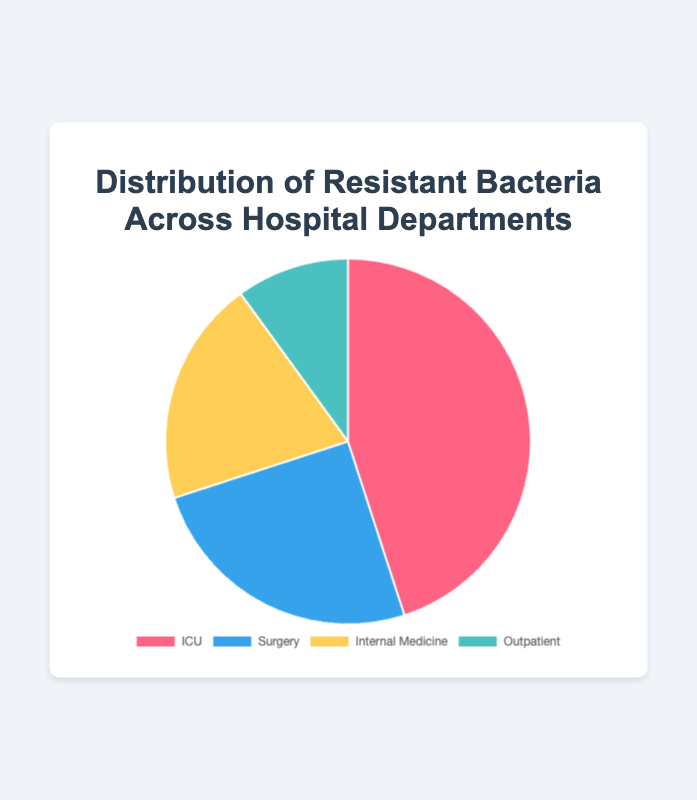Which department has the highest percentage of resistant bacteria? The department with the largest portion of the pie chart represents the highest percentage. The ICU department has the largest portion.
Answer: ICU What is the combined percentage of resistant bacteria in the Surgery and Internal Medicine departments? Add the percentages of resistant bacteria in the Surgery (25%) and Internal Medicine (20%) departments: 25% + 20% = 45%.
Answer: 45% Which department has the smallest percentage of resistant bacteria, and what is that percentage? The department with the smallest portion of the pie chart has the smallest percentage. The Outpatient department has the smallest portion, and its percentage is 10%.
Answer: Outpatient, 10% By how much does the percentage of resistant bacteria in the ICU department exceed that in the Outpatient department? Subtract the percentage of resistant bacteria in the Outpatient department (10%) from that in the ICU department (45%): 45% - 10% = 35%.
Answer: 35% What is the average percentage of resistant bacteria across all four departments? Add the percentages of resistant bacteria in all departments and then divide by the number of departments: (45% + 25% + 20% + 10%) / 4 = 100% / 4 = 25%.
Answer: 25% Which departments have a resistant bacteria percentage greater than 20%? Compare the percentages of all departments to find those greater than 20%. Both ICU (45%) and Surgery (25%) have percentages greater than 20%.
Answer: ICU, Surgery Which department's slice of the pie chart is colored yellow, and what is its percentage of resistant bacteria? Look at the color coding in the chart. The yellow slice represents Internal Medicine, which has 20% resistant bacteria.
Answer: Internal Medicine, 20% What is the difference in the percentage of resistant bacteria between the Surgery and Internal Medicine departments? Subtract the percentage in the Internal Medicine department (20%) from that in the Surgery department (25%): 25% - 20% = 5%.
Answer: 5% If you combine the resistant bacteria percentages of the departments with the smallest and largest values, what is the resulting percentage? Add the smallest percentage (Outpatient, 10%) to the largest percentage (ICU, 45%): 10% + 45% = 55%.
Answer: 55% What fraction of the total resistant bacteria does the Internal Medicine department represent? Divide the percentage of Internal Medicine resistant bacteria by the total percentage, 100%: 20% / 100% = 1/5.
Answer: 1/5 